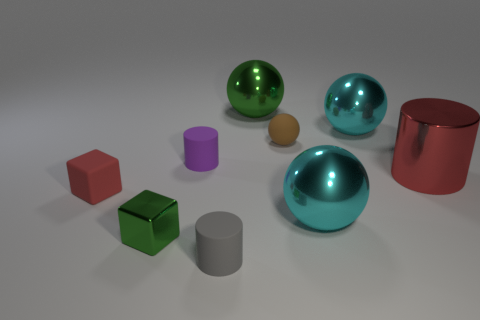Add 1 brown matte objects. How many objects exist? 10 Subtract all blocks. How many objects are left? 7 Add 6 large spheres. How many large spheres exist? 9 Subtract 0 cyan cylinders. How many objects are left? 9 Subtract all large cyan spheres. Subtract all green metal blocks. How many objects are left? 6 Add 4 green metallic objects. How many green metallic objects are left? 6 